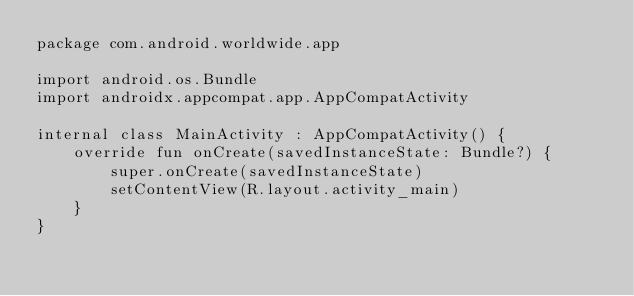<code> <loc_0><loc_0><loc_500><loc_500><_Kotlin_>package com.android.worldwide.app

import android.os.Bundle
import androidx.appcompat.app.AppCompatActivity

internal class MainActivity : AppCompatActivity() {
    override fun onCreate(savedInstanceState: Bundle?) {
        super.onCreate(savedInstanceState)
        setContentView(R.layout.activity_main)
    }
}
</code> 